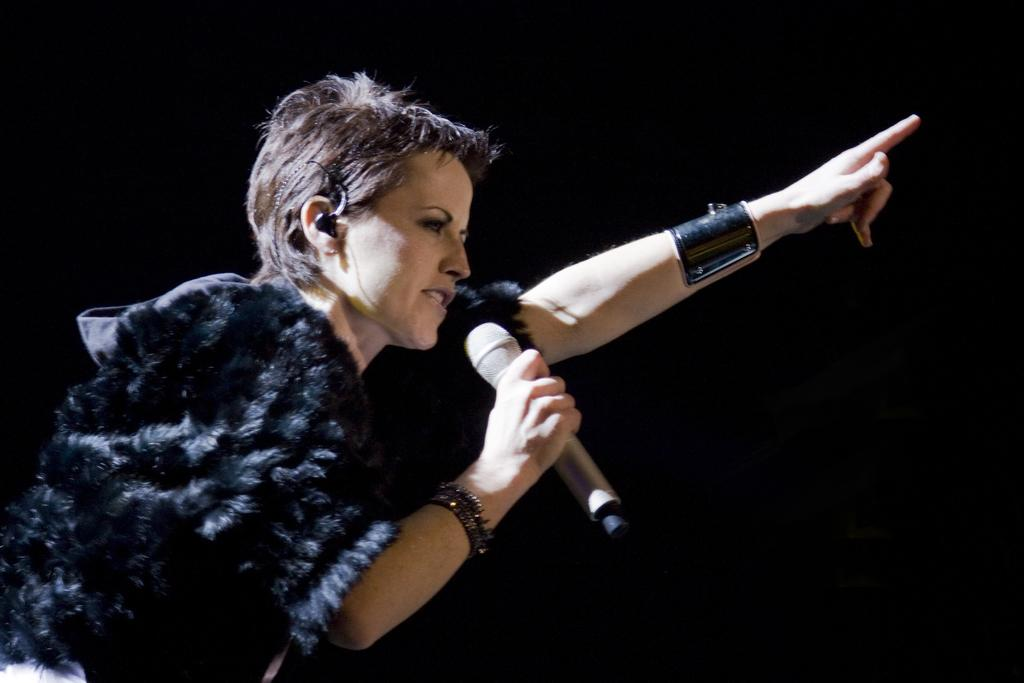Who is the main subject in the image? There is a girl in the image. Where is the girl located in the image? The girl is on the left side of the image. What is the girl holding in her hand? The girl is holding a mic in her hand. What type of cloth is the girl wearing in the image? There is no information provided about the girl's clothing in the image. Can you tell me where the nearest store is located in the image? There is no store present in the image. 